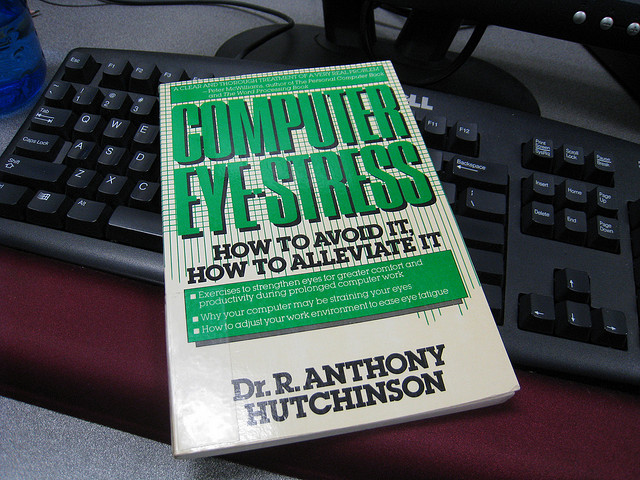<image>Where is a globe? There is no globe in the image. However, it can be on the desk or the computer. Where is a globe? I don't know where a globe is. It can be seen on the desk or below. 